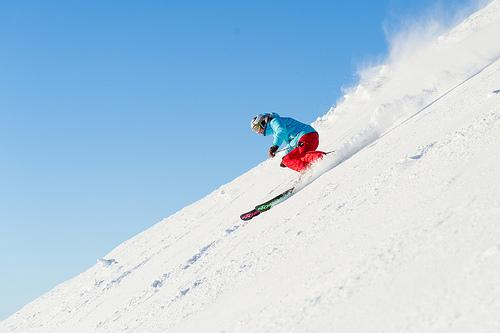Mention the different parts of the person's body that are visible in the image. The parts visible include the person's head, goggles, arm, hand, leg, thigh, and back. What is the main activity happening in the image? A person, possibly a woman, is skiing on snowy terrain. Choose an item from the image that could be used for a product advertisement. The skiing gear worn by the person, including the helmet, jacket, and goggles, could be used for a product advertisement. Can you describe the main object of focus and their attire? The main object of focus is a person wearing a helmet, goggles, and jacket, skiing on snow. In this image, what color is the sky and what is visible in it? The sky is blue with white clouds scattered around. Provide a brief description of the weather and how it shows in the image. The weather appears to be cold but clear, with snow on the ground and a blue sky with white clouds. For the referential expression grounding task, identify a specific object in the image related to the person's skiing attire. The goggles worn by the person are a specific object related to their skiing attire. What is the overall atmosphere portrayed in the image? The image portrays a lively and active atmosphere with a person skiing in a bright, snowy environment. In this image, what type of landscape is the person in? The person is in a snowy landscape with a clear blue sky and white clouds. For the multi-choice VQA task: Which of these objects is NOT present in the image? A) Ski B) Snowboard C) Helmet D) Jacket B) Snowboard 